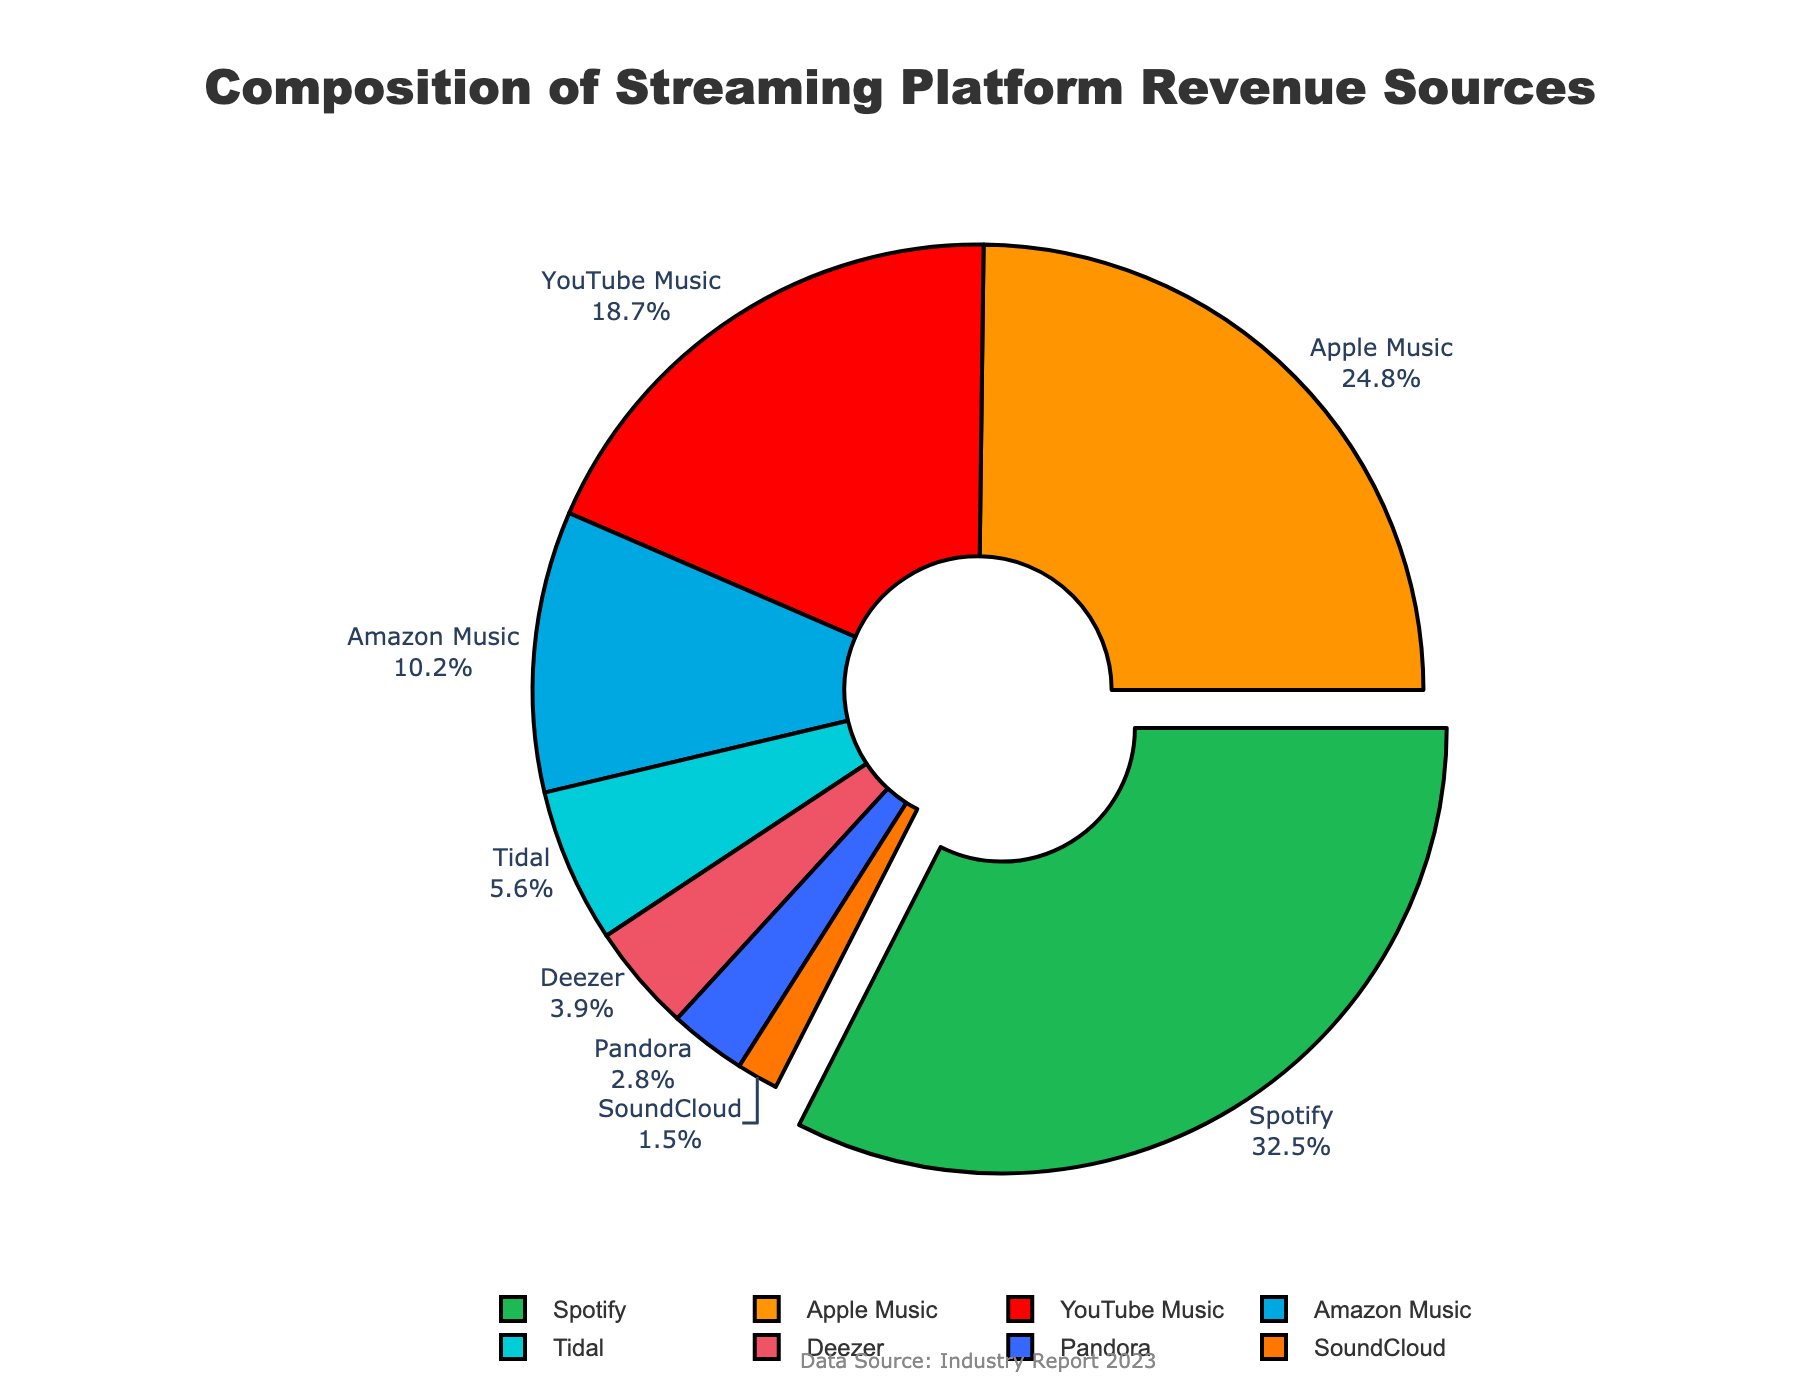Which platform contributes the largest percentage to the revenue? The slice representing Spotify is the largest and is also labeled with the highest percentage.
Answer: Spotify What is the total percentage of revenue from YouTube Music and Amazon Music combined? YouTube Music contributes 18.7% and Amazon Music contributes 10.2%. Summing these gives 18.7 + 10.2 = 28.9%.
Answer: 28.9% How much more is the revenue percentage of Spotify compared to Deezer? Spotify contributes 32.5% and Deezer contributes 3.9%. The difference is 32.5 - 3.9 = 28.6%.
Answer: 28.6% Which platform has the smallest contribution to the revenue, and what percentage is it? The smallest slice is labeled SoundCloud, with 1.5%.
Answer: SoundCloud, 1.5% If you were to combine the revenues from Deezer and Tidal, would their total surpass Amazon Music's revenue? Deezer contributes 3.9% and Tidal contributes 5.6%. Their sum is 3.9 + 5.6 = 9.5%, which is less than Amazon Music's 10.2%.
Answer: No How does the revenue percentage from Apple Music compare to that from Pandora? Apple Music contributes 24.8% and Pandora contributes 2.8%. Apple Music's revenue is significantly higher.
Answer: Apple Music is higher What is the combined percentage of the revenues from platforms with less than 10% contribution each? Deezer (3.9%), Pandora (2.8%), and SoundCloud (1.5%) each contribute less than 10%. Their sum is 3.9 + 2.8 + 1.5 = 8.2%.
Answer: 8.2% How many platforms contribute more than 20% each to the total revenue? Only Spotify (32.5%) and Apple Music (24.8%) contribute more than 20% each.
Answer: 2 By how much does the revenue of YouTube Music exceed that of SoundCloud? YouTube Music contributes 18.7% and SoundCloud contributes 1.5%. The difference is 18.7 - 1.5 = 17.2%.
Answer: 17.2% What is the average revenue percentage of Spotify, Apple Music, and YouTube Music? The contributions are Spotify (32.5%), Apple Music (24.8%), and YouTube Music (18.7%). The average is (32.5 + 24.8 + 18.7) / 3 = 25.33%.
Answer: 25.33% 